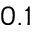Convert formula to latex. <formula><loc_0><loc_0><loc_500><loc_500>0 . 1</formula> 